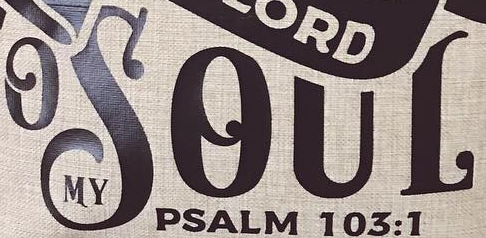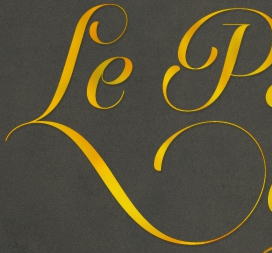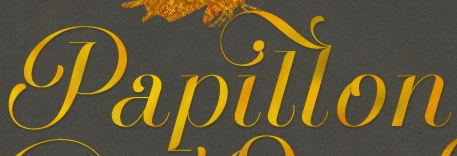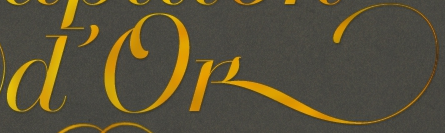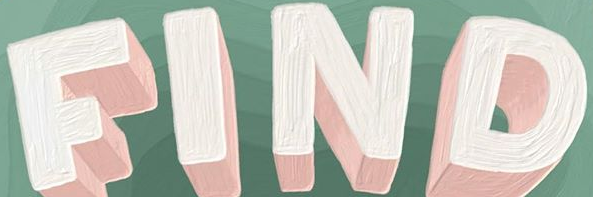What text is displayed in these images sequentially, separated by a semicolon? OSOUL; Le; Papillon; D'ok; FIND 